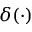Convert formula to latex. <formula><loc_0><loc_0><loc_500><loc_500>\delta ( \cdot )</formula> 